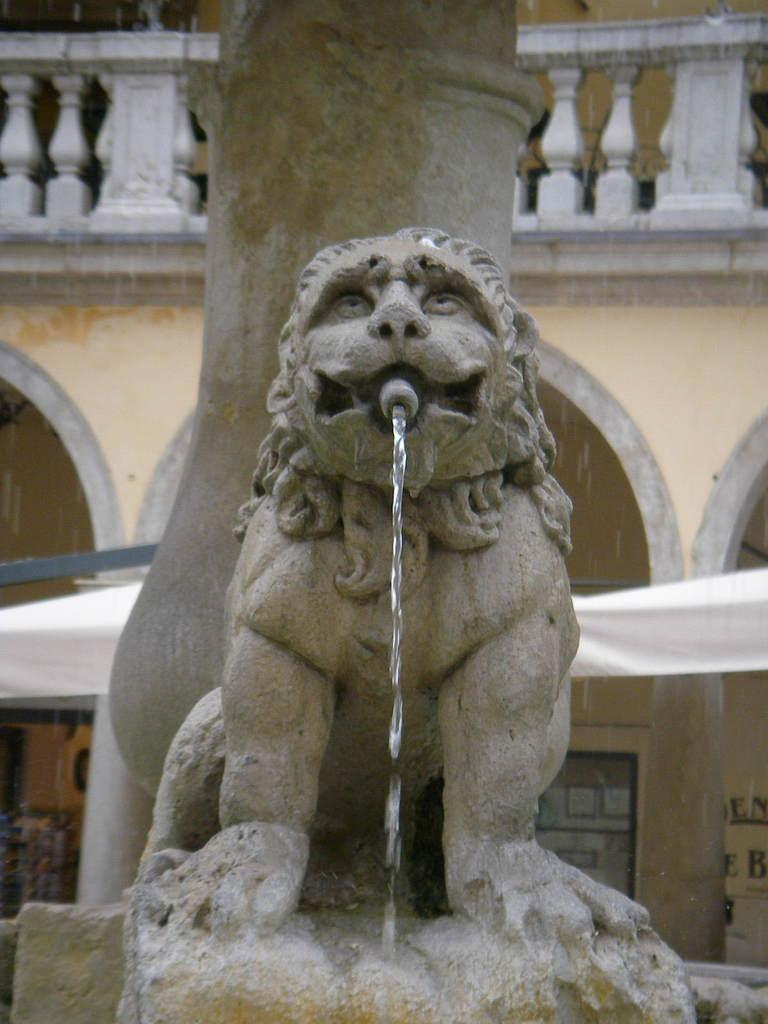What is the main feature in the image? There is a fountain in the image. Can you describe the setting of the image? There is a building in the background of the image. What color is the pen used to write on the fountain in the image? There is no pen or writing present on the fountain in the image. 